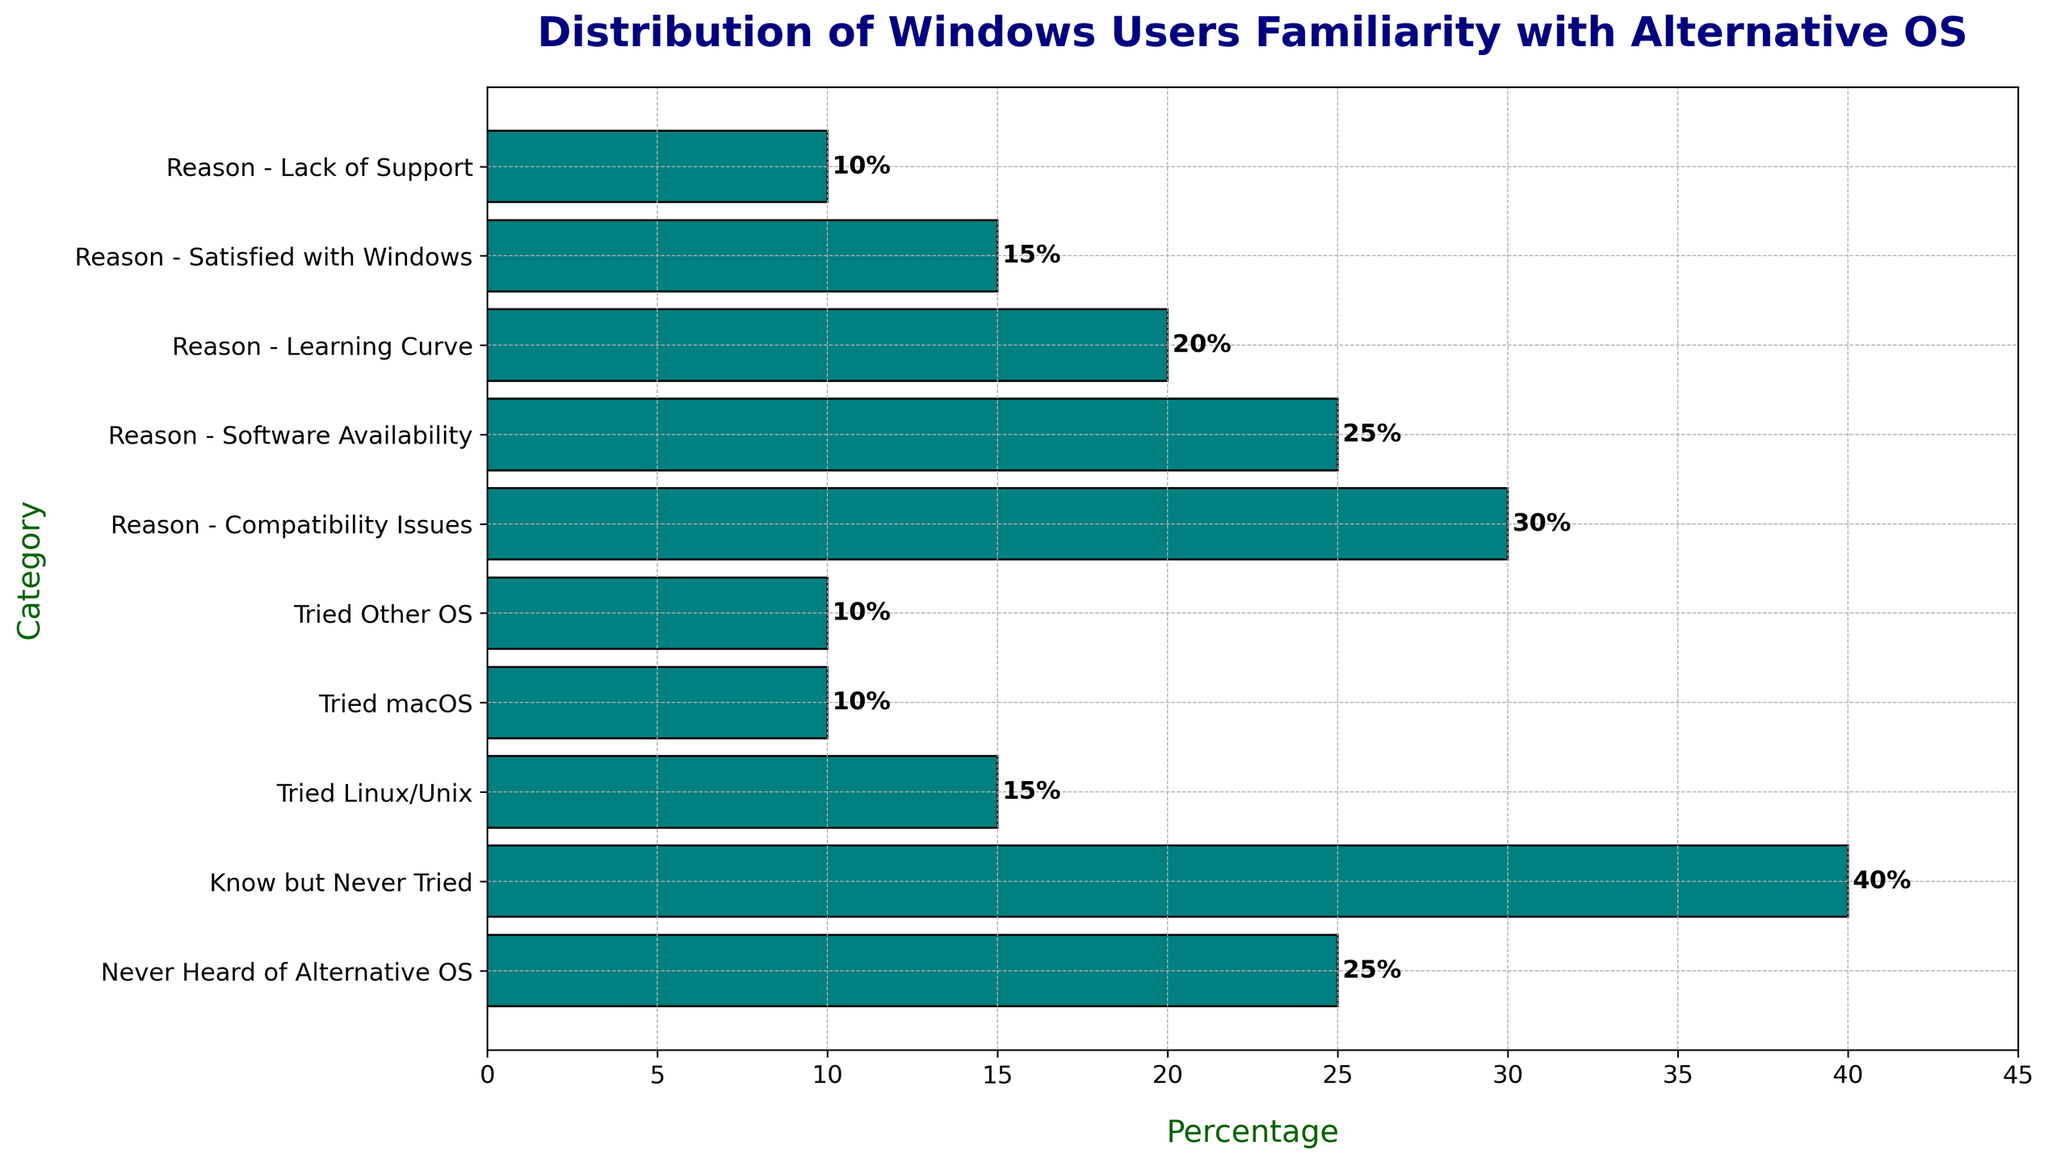What's the total percentage of Windows users who have tried an alternative OS? The relevant categories are "Tried Linux/Unix", "Tried macOS", and "Tried Other OS". Sum the percentages: 15% + 10% + 10% = 35%.
Answer: 35% Which single category has the highest percentage among familiarity with alternative OS sections? From the bar chart, the highest percentage among familiarity categories is "Know but Never Tried" with 40%.
Answer: Know but Never Tried Among the reasons for not switching, which reason has the lowest percentage? The "Lack of Support" reason has the lowest percentage at 10%, as seen on the bar chart.
Answer: Lack of Support What's the difference between the highest and lowest percentages in the reasons for not switching? The highest percentage is 30% ("Compatibility Issues") and the lowest is 10% ("Lack of Support"). The difference is 30% - 10% = 20%.
Answer: 20% How do the combined percentages of "Compatibility Issues" and "Software Availability" compare to the total percentage of familiarity with alternative OS sections? Combined, "Compatibility Issues" and "Software Availability" are 30% + 25% = 55%. Total familiarity percentages are 25% + 40% + 15% + 10% + 10% = 100%. 55% is more than half of the total 100%.
Answer: More than half What percentage of users are either "Satisfied with Windows" or "Lack of Support" as reasons for not switching? Sum the percentages of "Satisfied with Windows" and "Lack of Support": 15% + 10% = 25%.
Answer: 25% Does the percentage of users who have "Never Heard of Alternative OS" exceed the percentage of those who find the "Learning Curve" too steep? Yes, "Never Heard of Alternative OS" is 25%, while "Learning Curve" is 20%. 25% > 20%.
Answer: Yes How much higher is the percentage of users who "Know but Never Tried" alternative OS compared to those who have "Tried Linux/Unix"? "Know but Never Tried" is 40% and "Tried Linux/Unix" is 15%. The difference is 40% - 15% = 25%.
Answer: 25% Is the visual difference between the bars for "Software Availability" and "Learning Curve" more than 5%? "Software Availability" is 25% and "Learning Curve" is 20%. The difference visually and numerically is 25% - 20% = 5%, so they are equal in this context.
Answer: No 